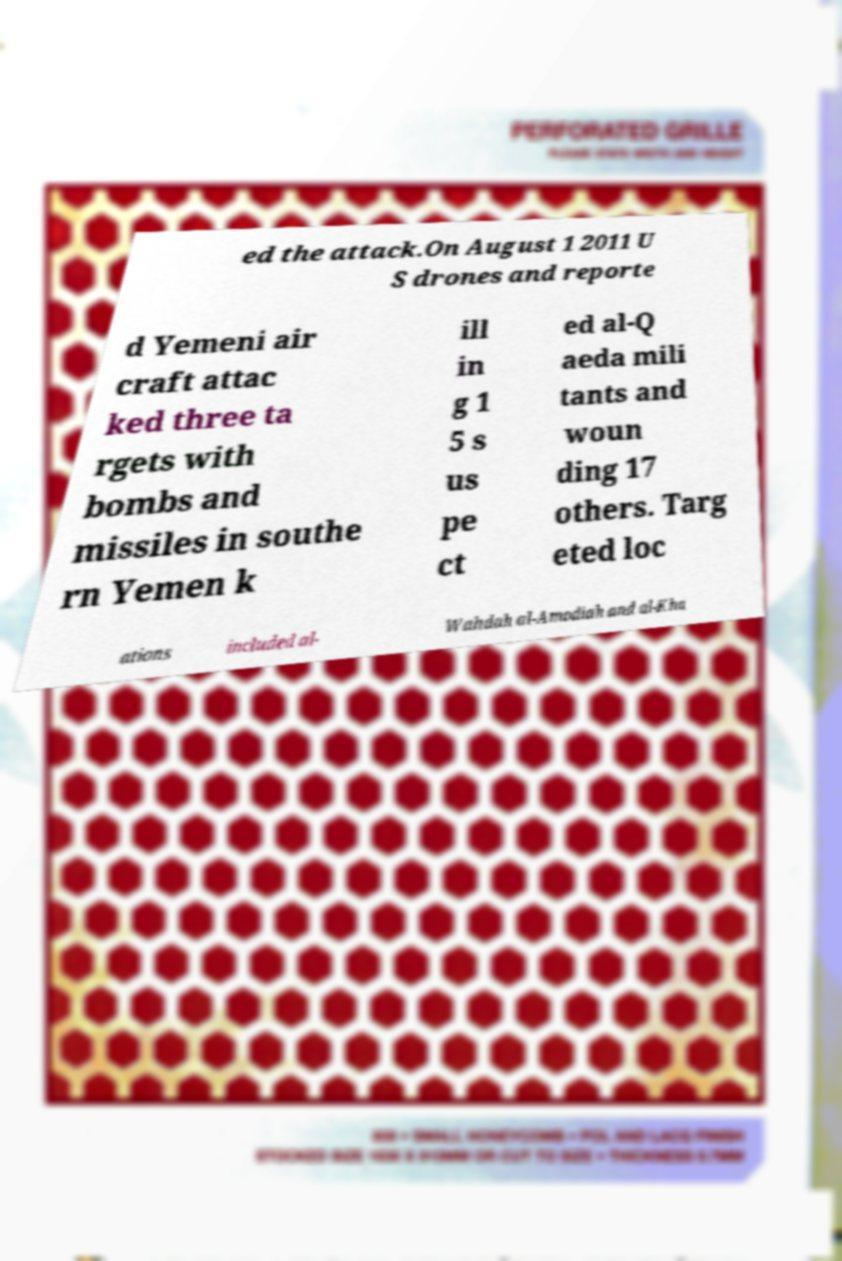Please read and relay the text visible in this image. What does it say? ed the attack.On August 1 2011 U S drones and reporte d Yemeni air craft attac ked three ta rgets with bombs and missiles in southe rn Yemen k ill in g 1 5 s us pe ct ed al-Q aeda mili tants and woun ding 17 others. Targ eted loc ations included al- Wahdah al-Amodiah and al-Kha 